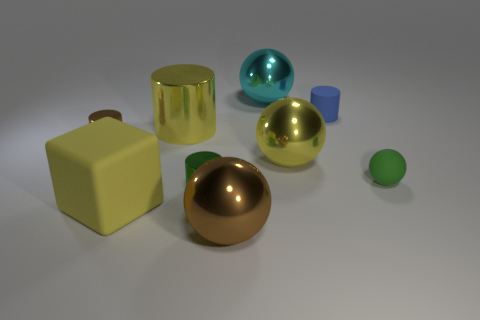Subtract all small balls. How many balls are left? 3 Subtract all yellow cylinders. How many cylinders are left? 3 Subtract all cylinders. How many objects are left? 5 Add 1 big purple metallic things. How many objects exist? 10 Subtract all gray cubes. How many blue cylinders are left? 1 Add 9 brown spheres. How many brown spheres are left? 10 Add 2 big blue cubes. How many big blue cubes exist? 2 Subtract 0 red blocks. How many objects are left? 9 Subtract 1 cubes. How many cubes are left? 0 Subtract all gray spheres. Subtract all yellow cubes. How many spheres are left? 4 